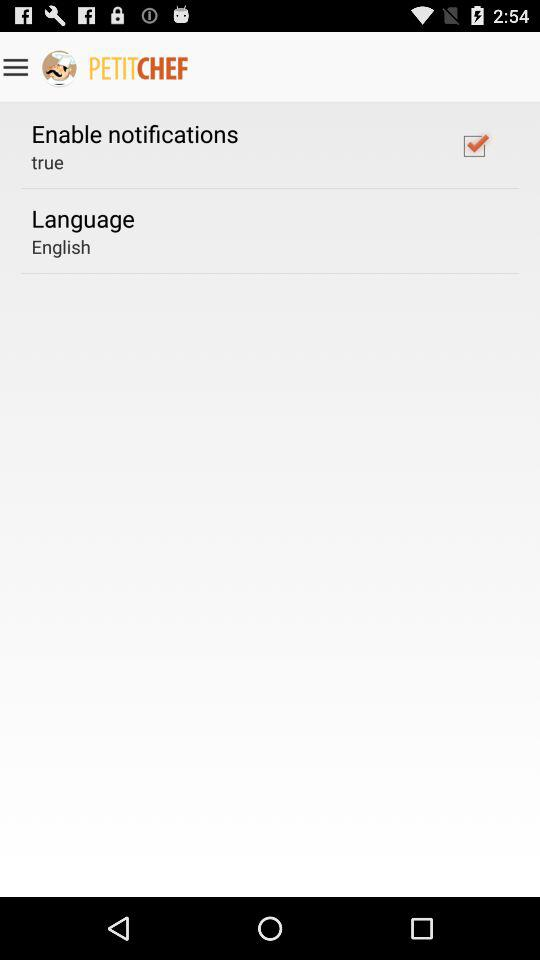What's the status of "Enable notifications"? The status of "Enable notifications" is "on". 